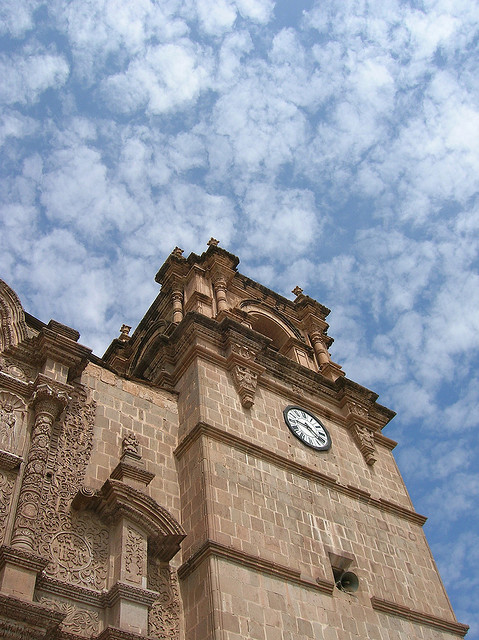<image>How many bricks make up the section of building visible in the picture? I am not sure about the exact number of bricks that would make up the section of the building visible in the picture. The number could be anywhere from 200 to thousands. How many bricks make up the section of building visible in the picture? It is unknown how many bricks make up the section of building visible in the picture. There can be thousands of bricks or even more. 